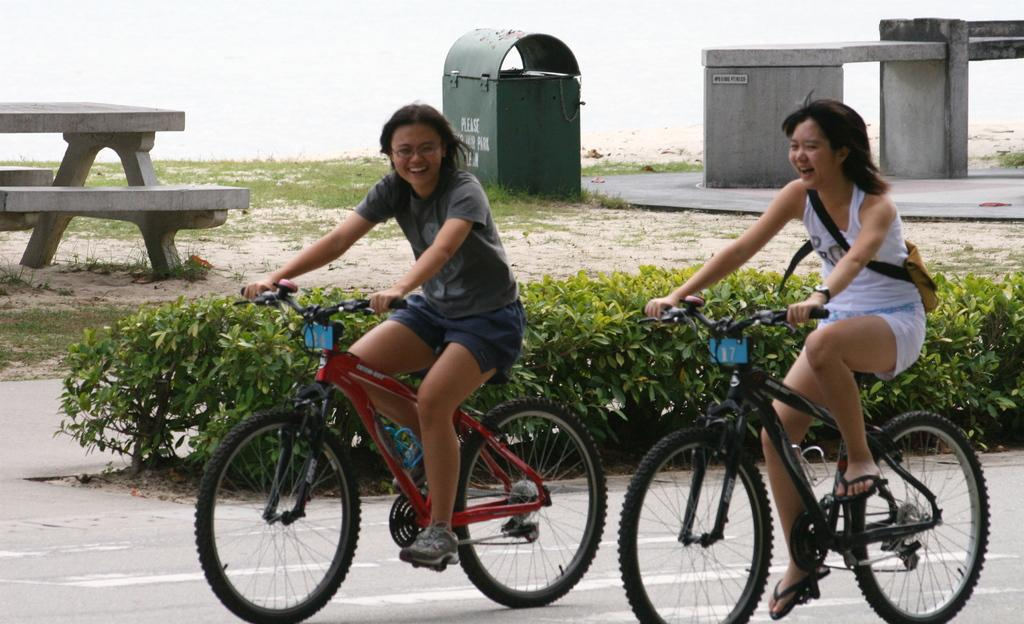How many people are in the image? There are two people in the image. What are the people doing in the image? The people are riding bicycles. Where are the bicycles located in the image? The bicycles are on a road. What can be seen in the background of the image? There are plants, a bench, a dustbin, and an architectural structure in the background of the image. How many frogs are sitting on the bench in the image? There are no frogs present in the image; only the two people riding bicycles, the bicycles on the road, and the background elements are visible. 